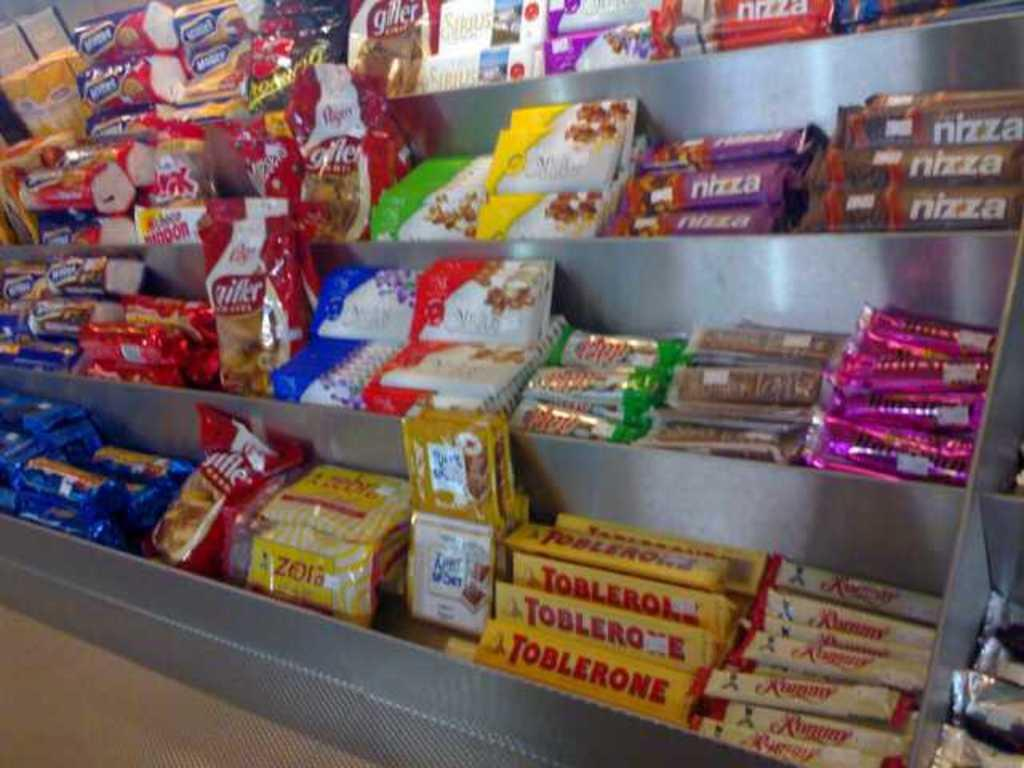<image>
Summarize the visual content of the image. A candy display offers nizza and other goodies. 